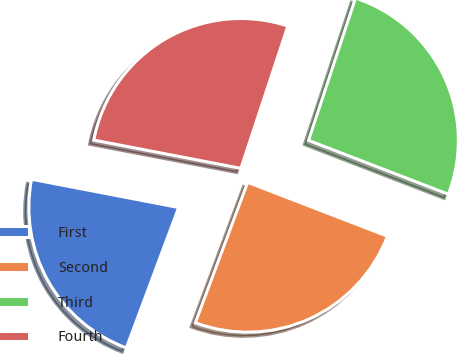<chart> <loc_0><loc_0><loc_500><loc_500><pie_chart><fcel>First<fcel>Second<fcel>Third<fcel>Fourth<nl><fcel>22.34%<fcel>24.82%<fcel>25.78%<fcel>27.05%<nl></chart> 